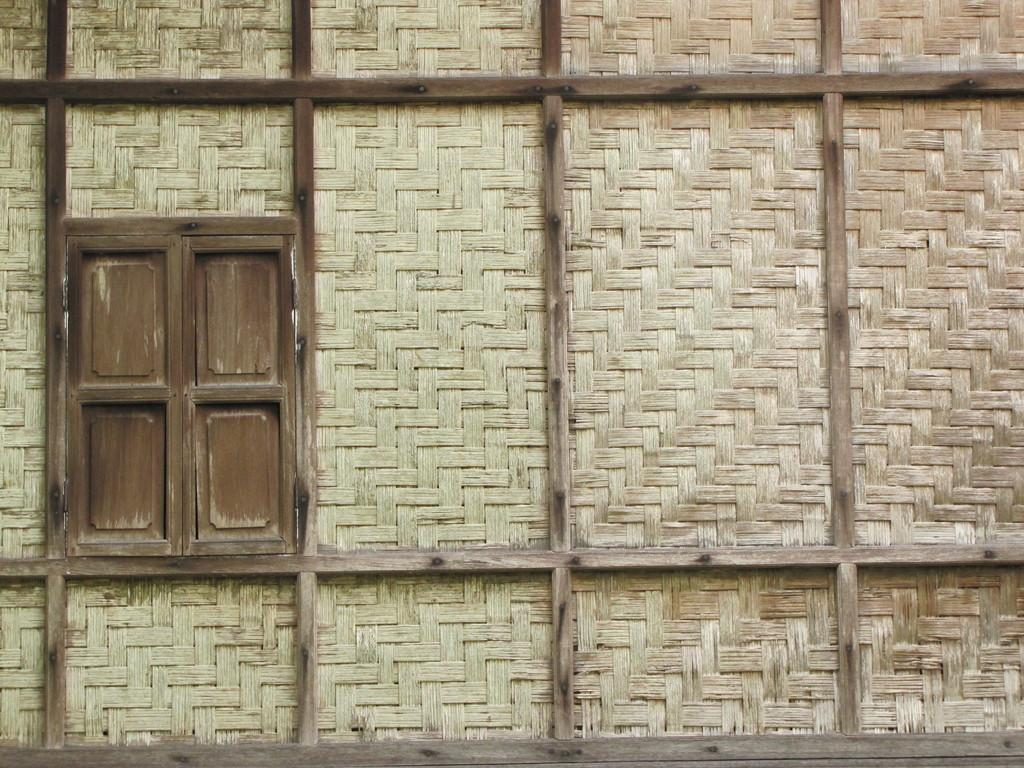What is located on the left side of the image? There is a window on the left side of the image. What is on the opposite side of the window? There is a wall on the right side of the image. What materials were used to construct the wall? The wall is made up of sticks and straws. How many horses can be seen grazing in the image? There are no horses present in the image. What type of observation can be made from the window in the image? The image does not provide any information about what can be observed from the window. 